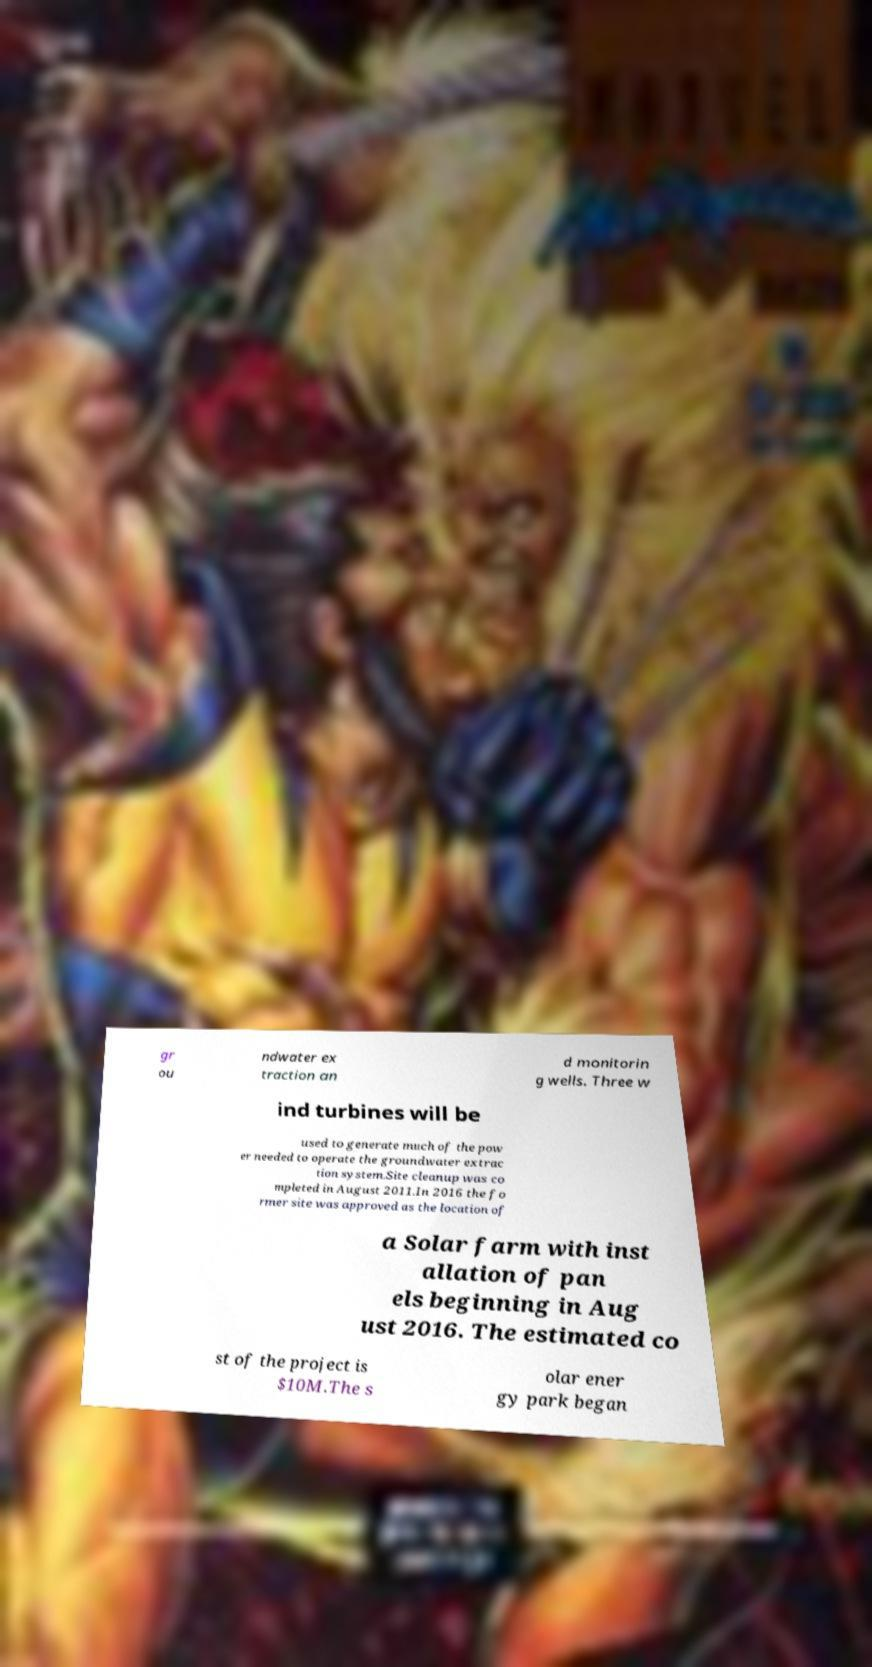Please read and relay the text visible in this image. What does it say? gr ou ndwater ex traction an d monitorin g wells. Three w ind turbines will be used to generate much of the pow er needed to operate the groundwater extrac tion system.Site cleanup was co mpleted in August 2011.In 2016 the fo rmer site was approved as the location of a Solar farm with inst allation of pan els beginning in Aug ust 2016. The estimated co st of the project is $10M.The s olar ener gy park began 